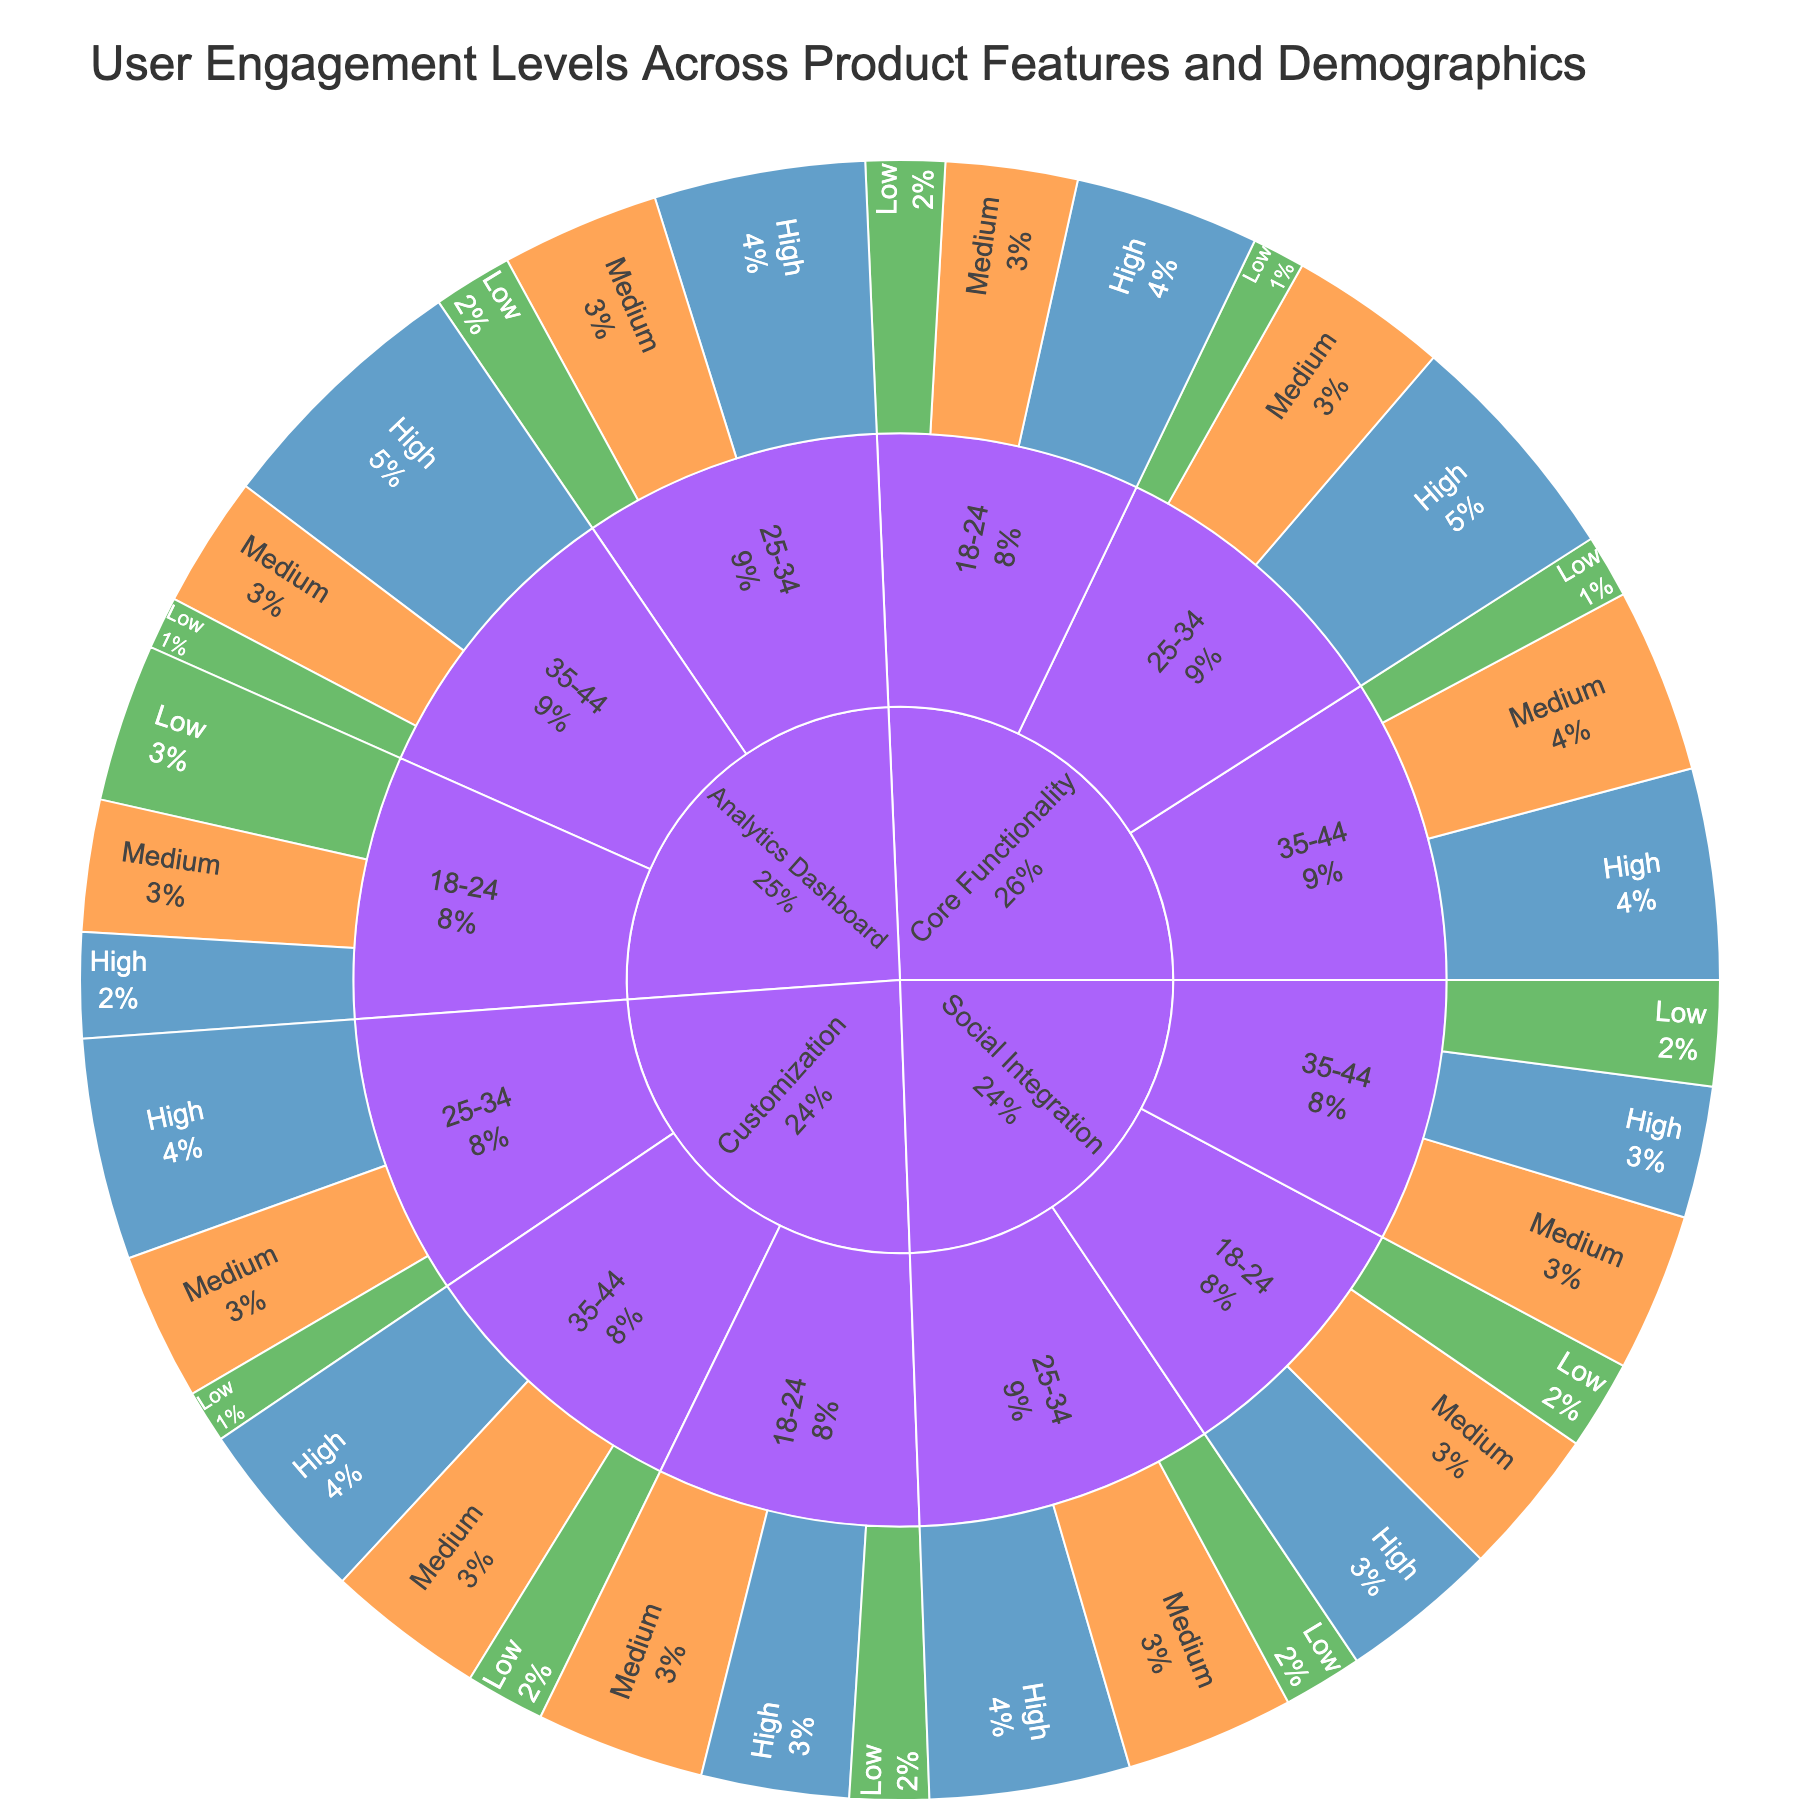What is the most engaged feature among users aged 18-24? Users aged 18-24 have the highest engagement (High) with the Core Functionality feature, represented by the largest segment in the inner ring for this demographic.
Answer: Core Functionality Which feature has the least engagement (Low) across users aged 25-34? The Analytics Dashboard feature has the least engagement among users aged 25-34, with the Low engagement segment being smallest.
Answer: Analytics Dashboard What's the total user engagement value for the Social Integration feature across all age groups? To find the total for Social Integration, sum the engagement values across all age groups (30+28+17+38+32+15+25+30+20), totaling 235.
Answer: 235 Compare the High engagement levels between Core Functionality and Customization for users aged 35-44. Which feature has higher engagement? Core Functionality has a High engagement value of 40 for users aged 35-44, whereas Customization has a High engagement value of 35, implying Core Functionality has higher engagement.
Answer: Core Functionality What percentage of the 25-34 age group engages highly with Customization? The High engagement value for Customization in the 25-34 age group is 42. The total engagement for Customization in this group is (42+28+10) = 80. The percentage is (42/80) * 100 = 52.5%.
Answer: 52.5% Which engagement level has the highest value in the Analytics Dashboard feature for the 35-44 demographic? The High engagement level has the highest value (50) in the Analytics Dashboard feature for the 35-44 demographic.
Answer: High What's the difference in Medium engagement levels between Social Integration and Analytics Dashboard in the 18-24 age group? The Medium engagement for Social Integration is 28, and for Analytics Dashboard, it is 25. The difference is 28 - 25 = 3.
Answer: 3 Compare the total engagement values for Core Functionality and Social Integration across all age groups. Which feature has higher total engagement? Summing up for Core Functionality: (35+25+15+45+30+10+40+35+12) = 247. For Social Integration: (30+28+17+38+32+15+25+30+20) = 235. Core Functionality has higher total engagement.
Answer: Core Functionality 